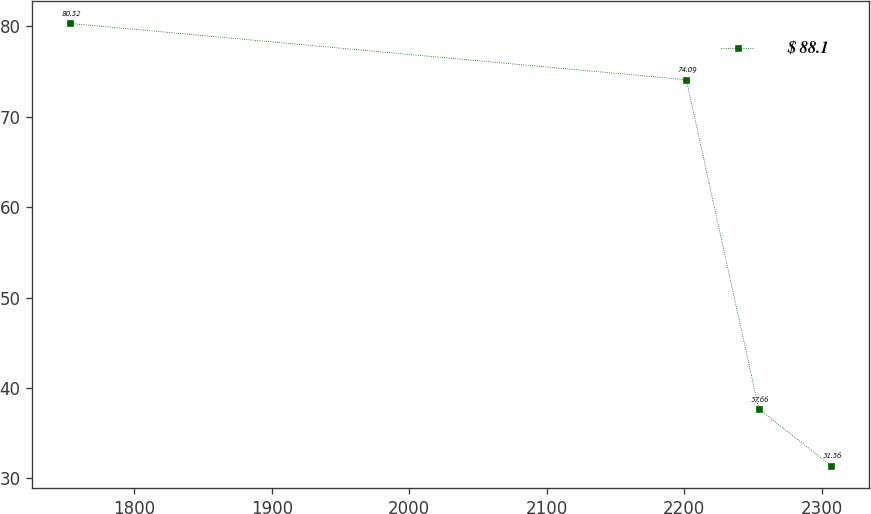Convert chart to OTSL. <chart><loc_0><loc_0><loc_500><loc_500><line_chart><ecel><fcel>$ 88.1<nl><fcel>1753.5<fcel>80.32<nl><fcel>2201.59<fcel>74.09<nl><fcel>2254.33<fcel>37.66<nl><fcel>2307.07<fcel>31.36<nl></chart> 